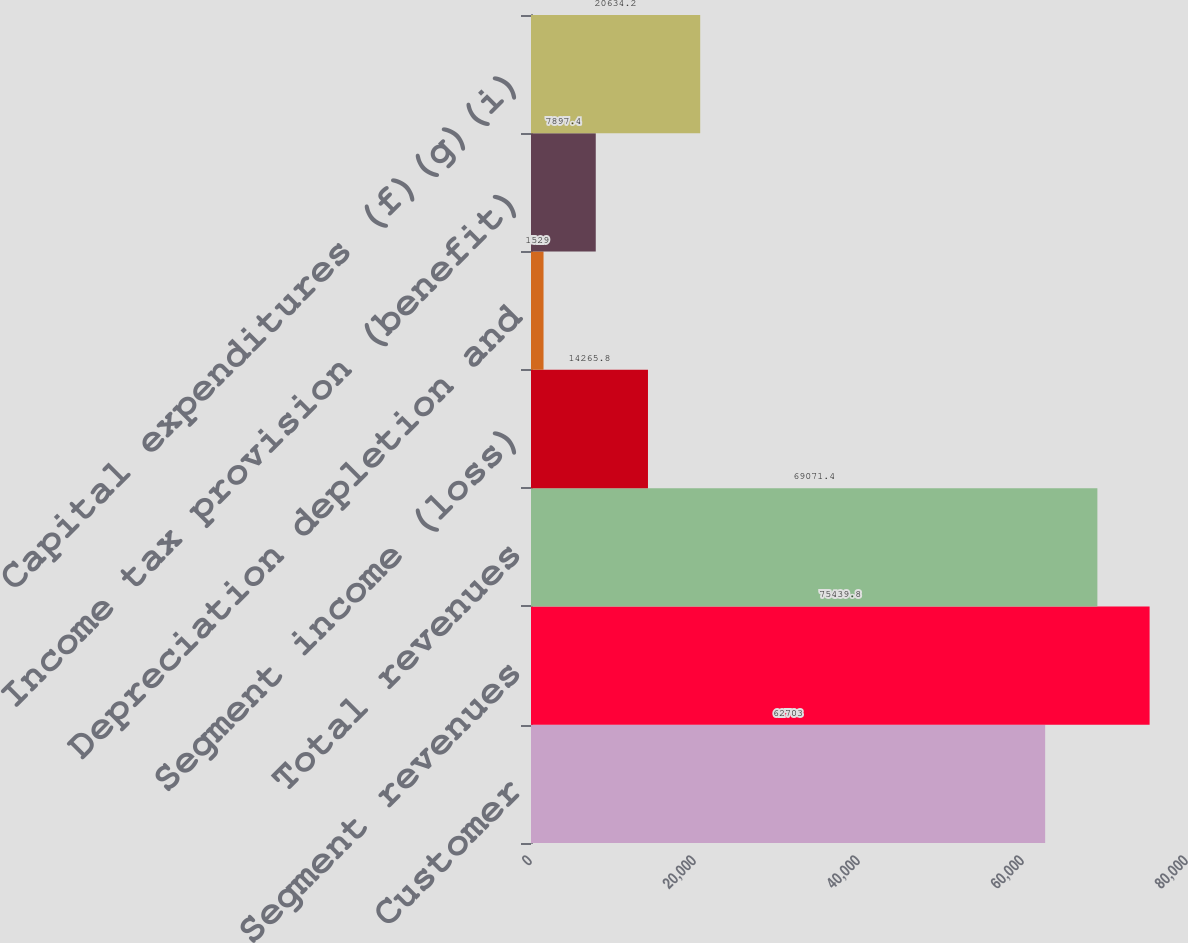<chart> <loc_0><loc_0><loc_500><loc_500><bar_chart><fcel>Customer<fcel>Segment revenues<fcel>Total revenues<fcel>Segment income (loss)<fcel>Depreciation depletion and<fcel>Income tax provision (benefit)<fcel>Capital expenditures (f)(g)(i)<nl><fcel>62703<fcel>75439.8<fcel>69071.4<fcel>14265.8<fcel>1529<fcel>7897.4<fcel>20634.2<nl></chart> 